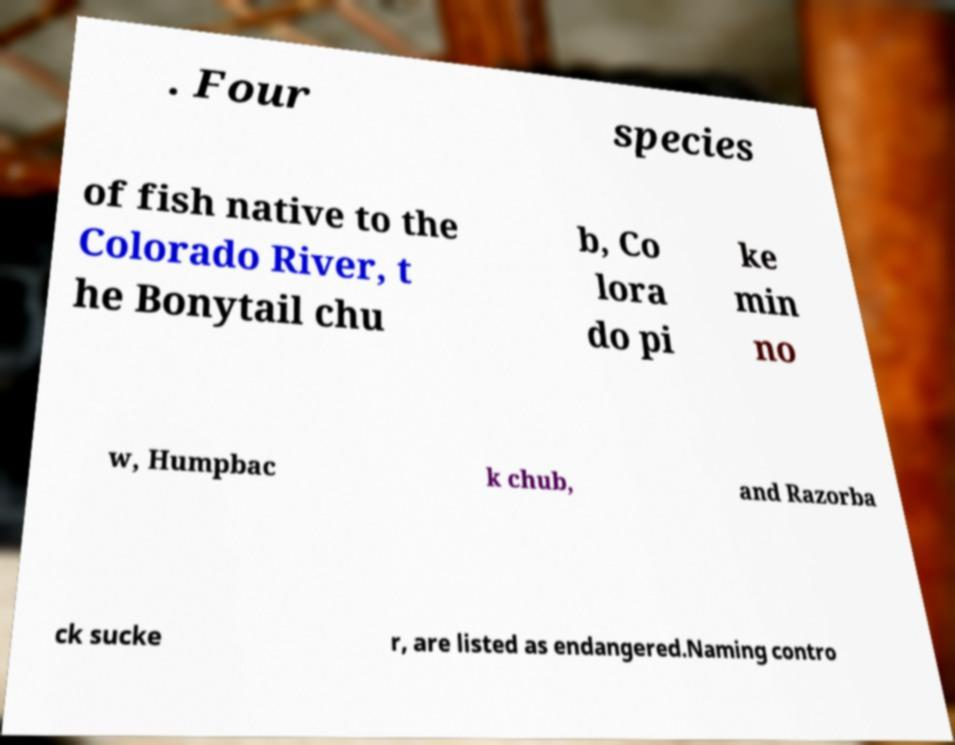What messages or text are displayed in this image? I need them in a readable, typed format. . Four species of fish native to the Colorado River, t he Bonytail chu b, Co lora do pi ke min no w, Humpbac k chub, and Razorba ck sucke r, are listed as endangered.Naming contro 